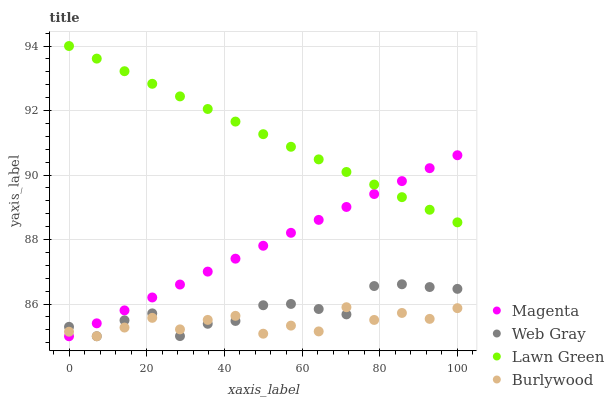Does Burlywood have the minimum area under the curve?
Answer yes or no. Yes. Does Lawn Green have the maximum area under the curve?
Answer yes or no. Yes. Does Magenta have the minimum area under the curve?
Answer yes or no. No. Does Magenta have the maximum area under the curve?
Answer yes or no. No. Is Magenta the smoothest?
Answer yes or no. Yes. Is Burlywood the roughest?
Answer yes or no. Yes. Is Lawn Green the smoothest?
Answer yes or no. No. Is Lawn Green the roughest?
Answer yes or no. No. Does Burlywood have the lowest value?
Answer yes or no. Yes. Does Lawn Green have the lowest value?
Answer yes or no. No. Does Lawn Green have the highest value?
Answer yes or no. Yes. Does Magenta have the highest value?
Answer yes or no. No. Is Web Gray less than Lawn Green?
Answer yes or no. Yes. Is Lawn Green greater than Burlywood?
Answer yes or no. Yes. Does Burlywood intersect Magenta?
Answer yes or no. Yes. Is Burlywood less than Magenta?
Answer yes or no. No. Is Burlywood greater than Magenta?
Answer yes or no. No. Does Web Gray intersect Lawn Green?
Answer yes or no. No. 